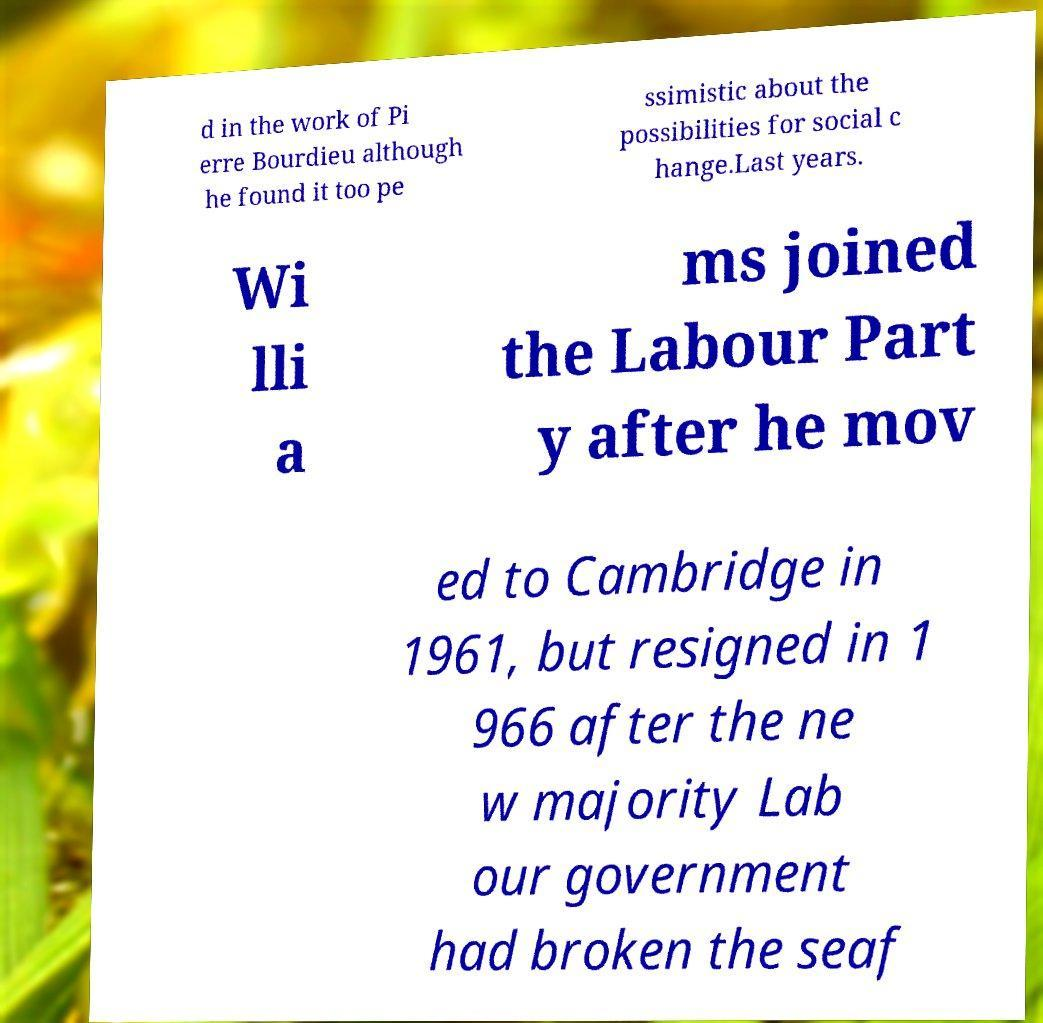Please read and relay the text visible in this image. What does it say? d in the work of Pi erre Bourdieu although he found it too pe ssimistic about the possibilities for social c hange.Last years. Wi lli a ms joined the Labour Part y after he mov ed to Cambridge in 1961, but resigned in 1 966 after the ne w majority Lab our government had broken the seaf 